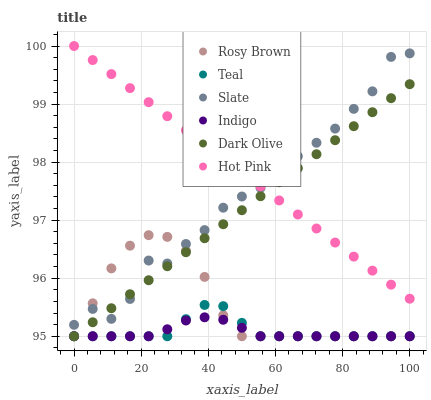Does Indigo have the minimum area under the curve?
Answer yes or no. Yes. Does Hot Pink have the maximum area under the curve?
Answer yes or no. Yes. Does Slate have the minimum area under the curve?
Answer yes or no. No. Does Slate have the maximum area under the curve?
Answer yes or no. No. Is Hot Pink the smoothest?
Answer yes or no. Yes. Is Slate the roughest?
Answer yes or no. Yes. Is Indigo the smoothest?
Answer yes or no. No. Is Indigo the roughest?
Answer yes or no. No. Does Rosy Brown have the lowest value?
Answer yes or no. Yes. Does Slate have the lowest value?
Answer yes or no. No. Does Hot Pink have the highest value?
Answer yes or no. Yes. Does Slate have the highest value?
Answer yes or no. No. Is Rosy Brown less than Hot Pink?
Answer yes or no. Yes. Is Hot Pink greater than Indigo?
Answer yes or no. Yes. Does Indigo intersect Dark Olive?
Answer yes or no. Yes. Is Indigo less than Dark Olive?
Answer yes or no. No. Is Indigo greater than Dark Olive?
Answer yes or no. No. Does Rosy Brown intersect Hot Pink?
Answer yes or no. No. 